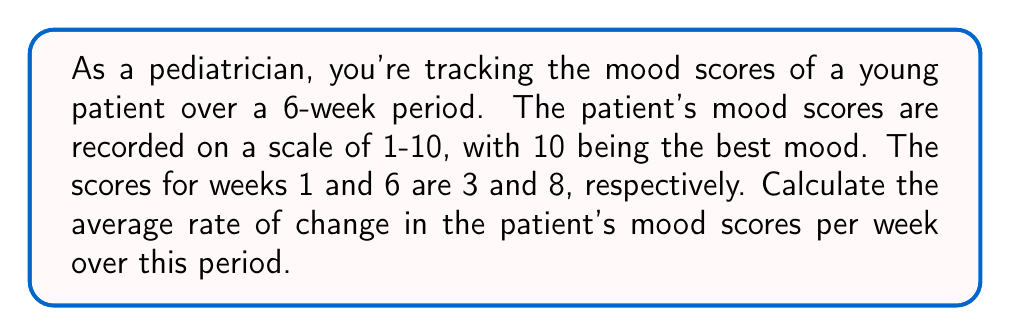Can you answer this question? To calculate the average rate of change, we need to use the formula:

$$ \text{Average rate of change} = \frac{\text{Change in y}}{\text{Change in x}} $$

Where:
- y represents the mood scores
- x represents the time in weeks

Step 1: Identify the initial and final values
- Initial mood score (y₁) = 3 (Week 1)
- Final mood score (y₂) = 8 (Week 6)
- Initial time (x₁) = 1 week
- Final time (x₂) = 6 weeks

Step 2: Calculate the change in y (mood scores)
$$ \Delta y = y_2 - y_1 = 8 - 3 = 5 $$

Step 3: Calculate the change in x (time)
$$ \Delta x = x_2 - x_1 = 6 - 1 = 5 \text{ weeks} $$

Step 4: Apply the average rate of change formula
$$ \text{Average rate of change} = \frac{\Delta y}{\Delta x} = \frac{5}{5} = 1 $$

Therefore, the average rate of change in the patient's mood scores is 1 point per week.
Answer: 1 point/week 